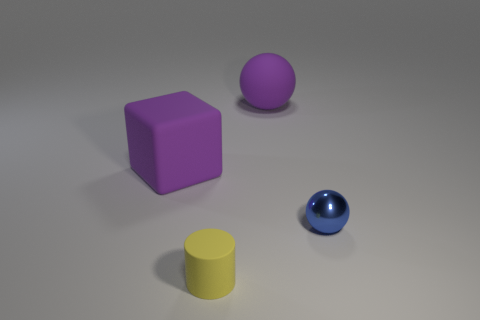Add 4 tiny matte things. How many objects exist? 8 Add 1 yellow matte objects. How many yellow matte objects are left? 2 Add 2 small brown metal spheres. How many small brown metal spheres exist? 2 Subtract all purple spheres. How many spheres are left? 1 Subtract 0 cyan cylinders. How many objects are left? 4 Subtract all cubes. How many objects are left? 3 Subtract 2 balls. How many balls are left? 0 Subtract all brown blocks. Subtract all purple spheres. How many blocks are left? 1 Subtract all red cylinders. How many brown balls are left? 0 Subtract all small cylinders. Subtract all purple spheres. How many objects are left? 2 